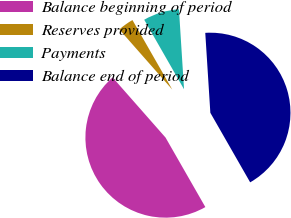Convert chart to OTSL. <chart><loc_0><loc_0><loc_500><loc_500><pie_chart><fcel>Balance beginning of period<fcel>Reserves provided<fcel>Payments<fcel>Balance end of period<nl><fcel>46.79%<fcel>3.21%<fcel>7.27%<fcel>42.73%<nl></chart> 